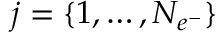<formula> <loc_0><loc_0><loc_500><loc_500>j = \{ 1 , \dots c , N _ { e ^ { - } } \}</formula> 